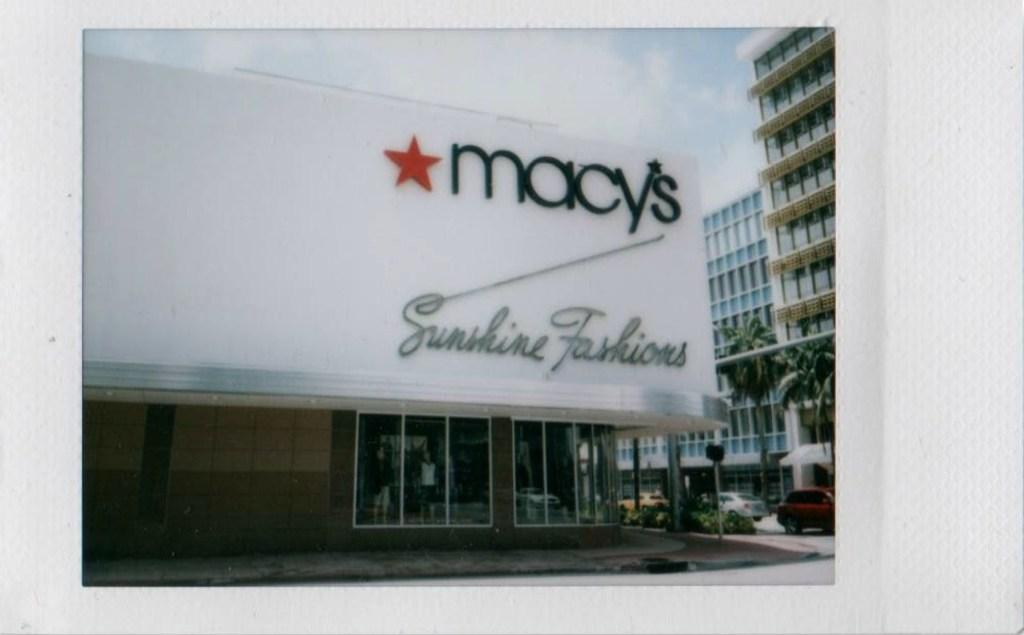What type of structures can be seen in the image? There are buildings in the image. What type of natural elements are present in the image? There are trees in the image. What type of vehicles are visible in the image? There are cars in the image. What type of figures are present in the image? There are mannequins in the image. Where is the heart located in the image? There is no heart present in the image. What type of sink is visible in the image? There is no sink present in the image. How many elbows can be seen in the image? There are no elbows present in the image. 